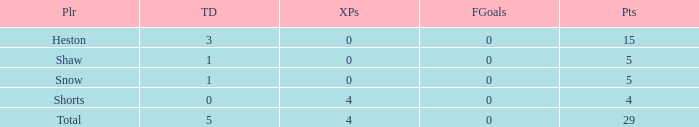What is the complete sum of field goals for a player who achieved below 3 touchdowns, gathered 4 points, and acquired under 4 supplementary points? 0.0. 